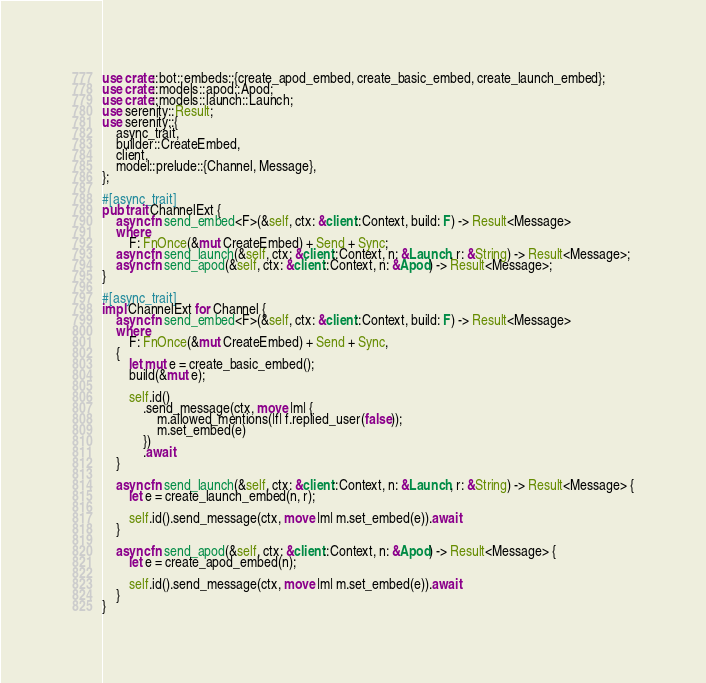<code> <loc_0><loc_0><loc_500><loc_500><_Rust_>use crate::bot::embeds::{create_apod_embed, create_basic_embed, create_launch_embed};
use crate::models::apod::Apod;
use crate::models::launch::Launch;
use serenity::Result;
use serenity::{
    async_trait,
    builder::CreateEmbed,
    client,
    model::prelude::{Channel, Message},
};

#[async_trait]
pub trait ChannelExt {
    async fn send_embed<F>(&self, ctx: &client::Context, build: F) -> Result<Message>
    where
        F: FnOnce(&mut CreateEmbed) + Send + Sync;
    async fn send_launch(&self, ctx: &client::Context, n: &Launch, r: &String) -> Result<Message>;
    async fn send_apod(&self, ctx: &client::Context, n: &Apod) -> Result<Message>;
}

#[async_trait]
impl ChannelExt for Channel {
    async fn send_embed<F>(&self, ctx: &client::Context, build: F) -> Result<Message>
    where
        F: FnOnce(&mut CreateEmbed) + Send + Sync,
    {
        let mut e = create_basic_embed();
        build(&mut e);

        self.id()
            .send_message(ctx, move |m| {
                m.allowed_mentions(|f| f.replied_user(false));
                m.set_embed(e)
            })
            .await
    }

    async fn send_launch(&self, ctx: &client::Context, n: &Launch, r: &String) -> Result<Message> {
        let e = create_launch_embed(n, r);

        self.id().send_message(ctx, move |m| m.set_embed(e)).await
    }

    async fn send_apod(&self, ctx: &client::Context, n: &Apod) -> Result<Message> {
        let e = create_apod_embed(n);

        self.id().send_message(ctx, move |m| m.set_embed(e)).await
    }
}
</code> 